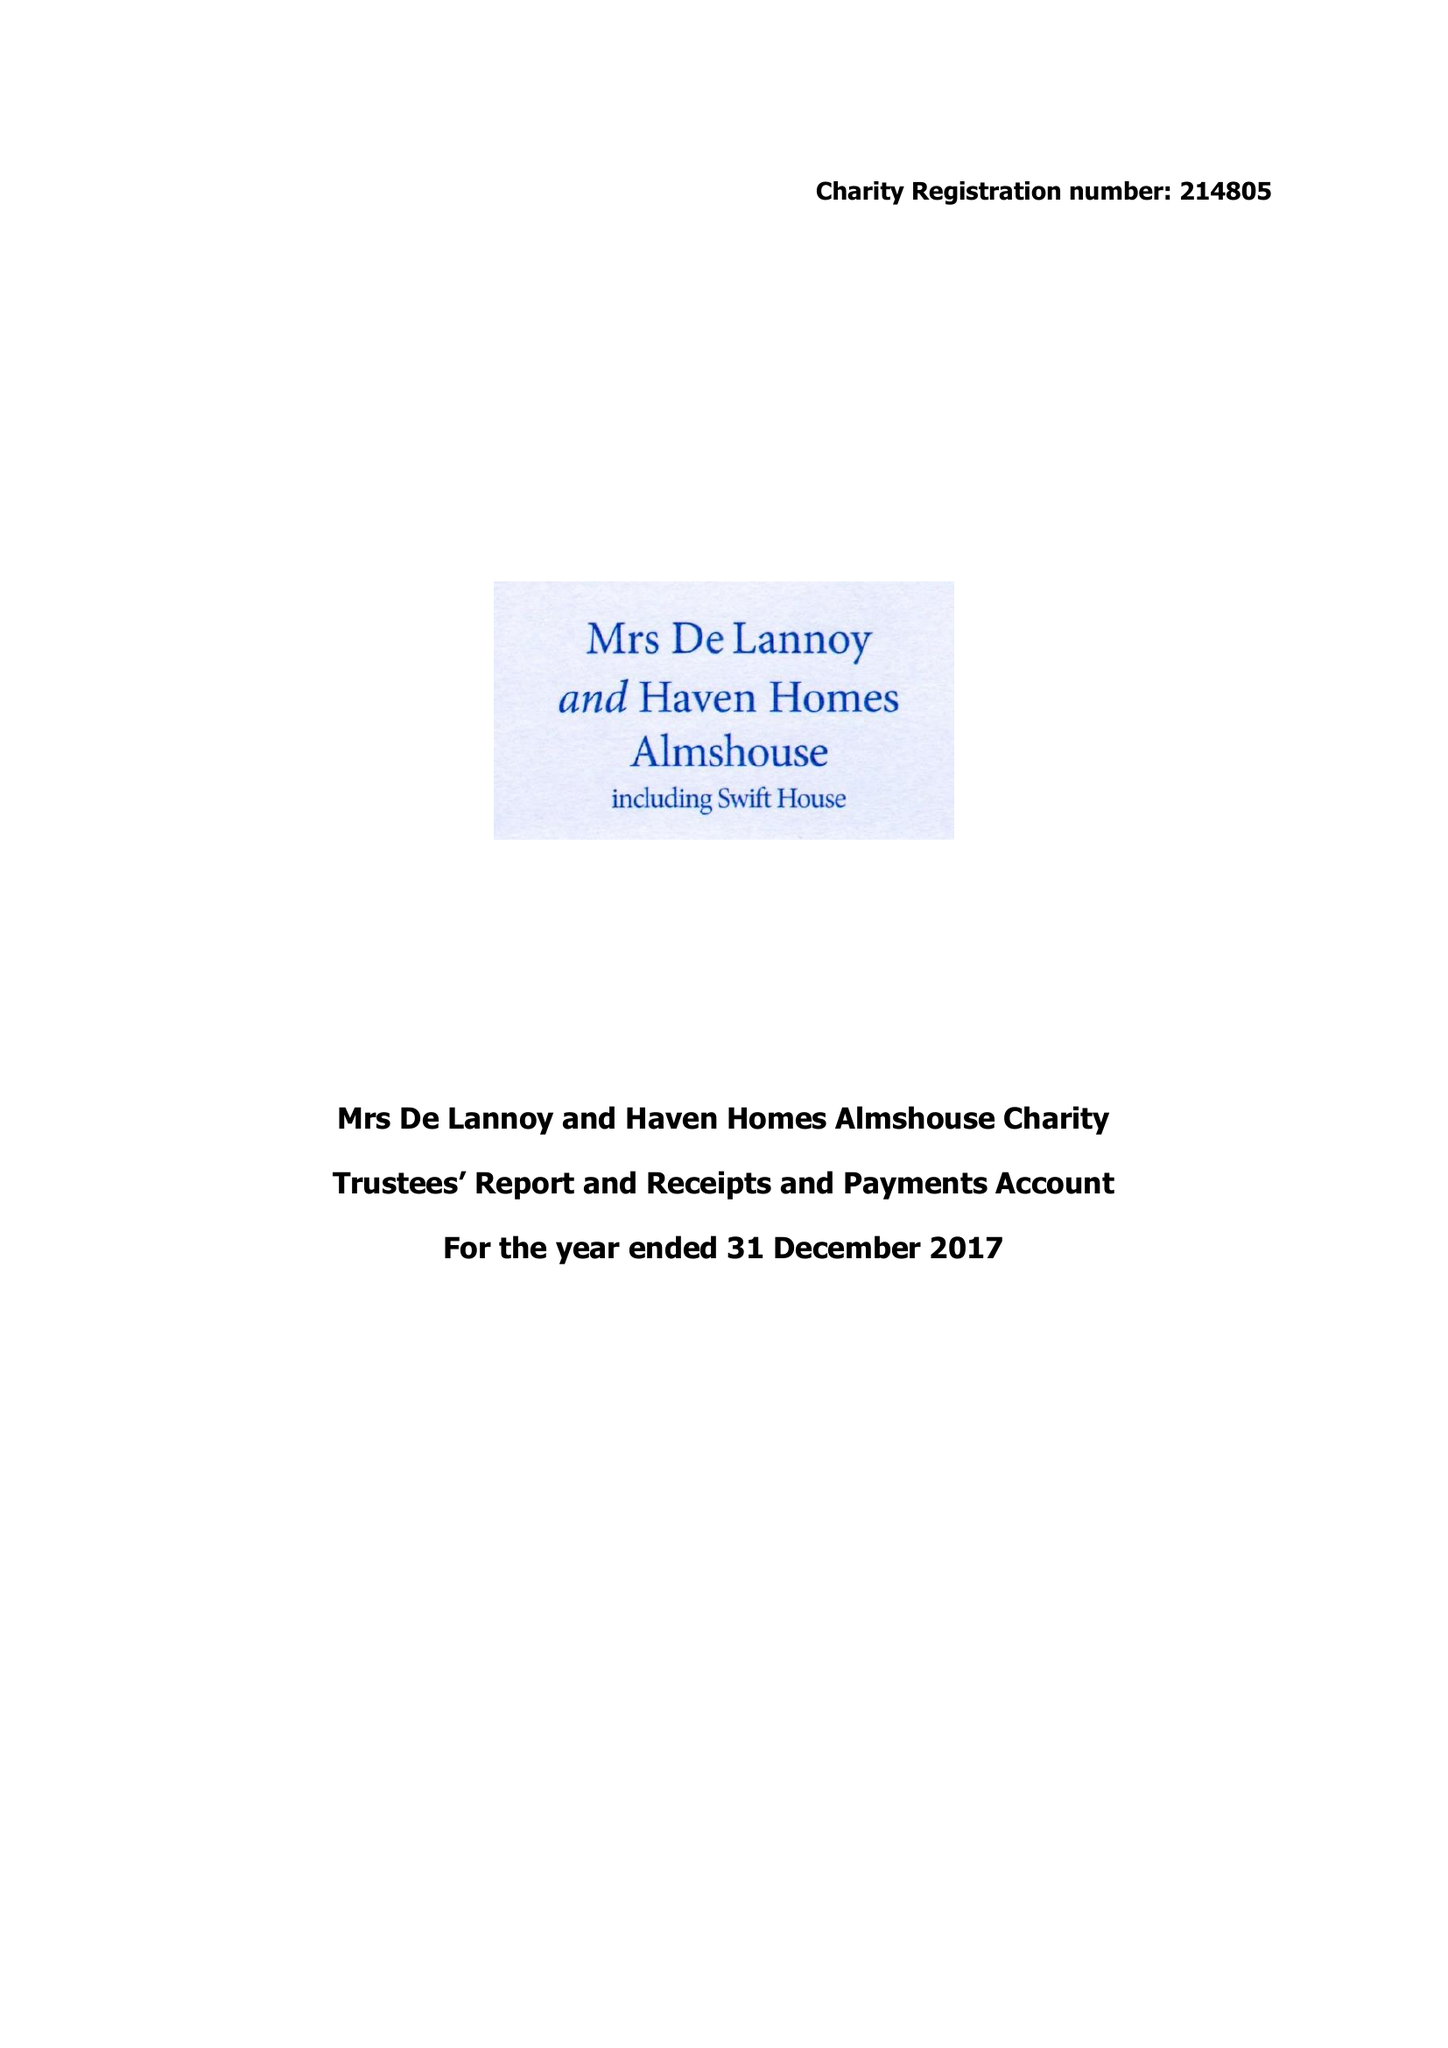What is the value for the spending_annually_in_british_pounds?
Answer the question using a single word or phrase. 38799.00 